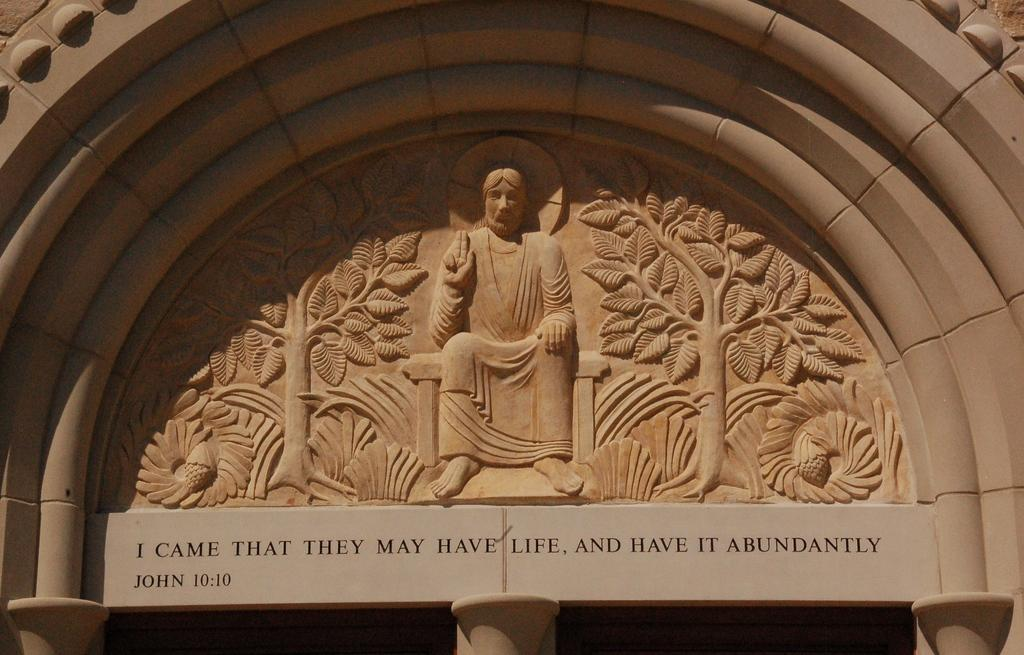What is the main subject in the image? There is a sculpture in the image. What else can be seen in the image besides the sculpture? There is text on the wall in the image. What type of receipt is attached to the sculpture in the image? There is no receipt present in the image. What kind of punishment is being depicted in the sculpture in the image? The sculpture does not depict any punishment; it is a standalone artwork. 